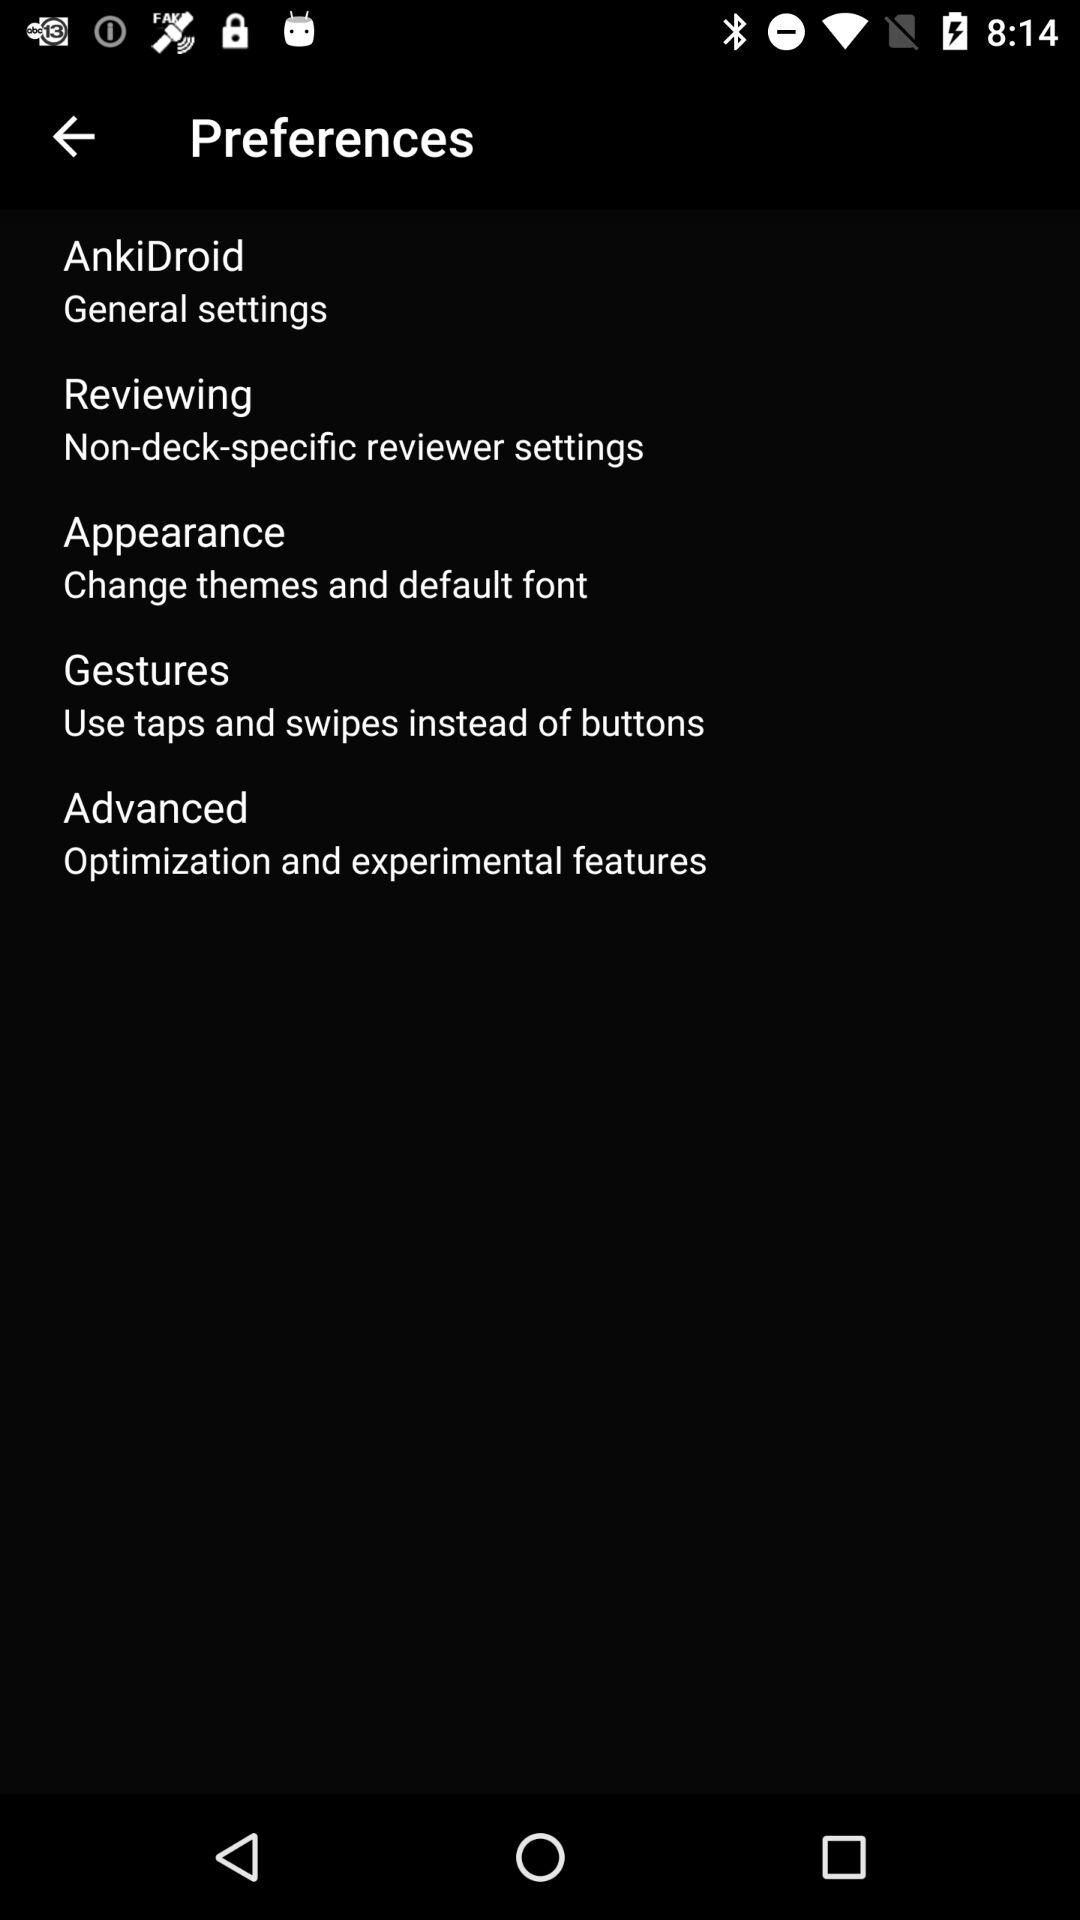How many sections are there in the preferences menu?
Answer the question using a single word or phrase. 5 